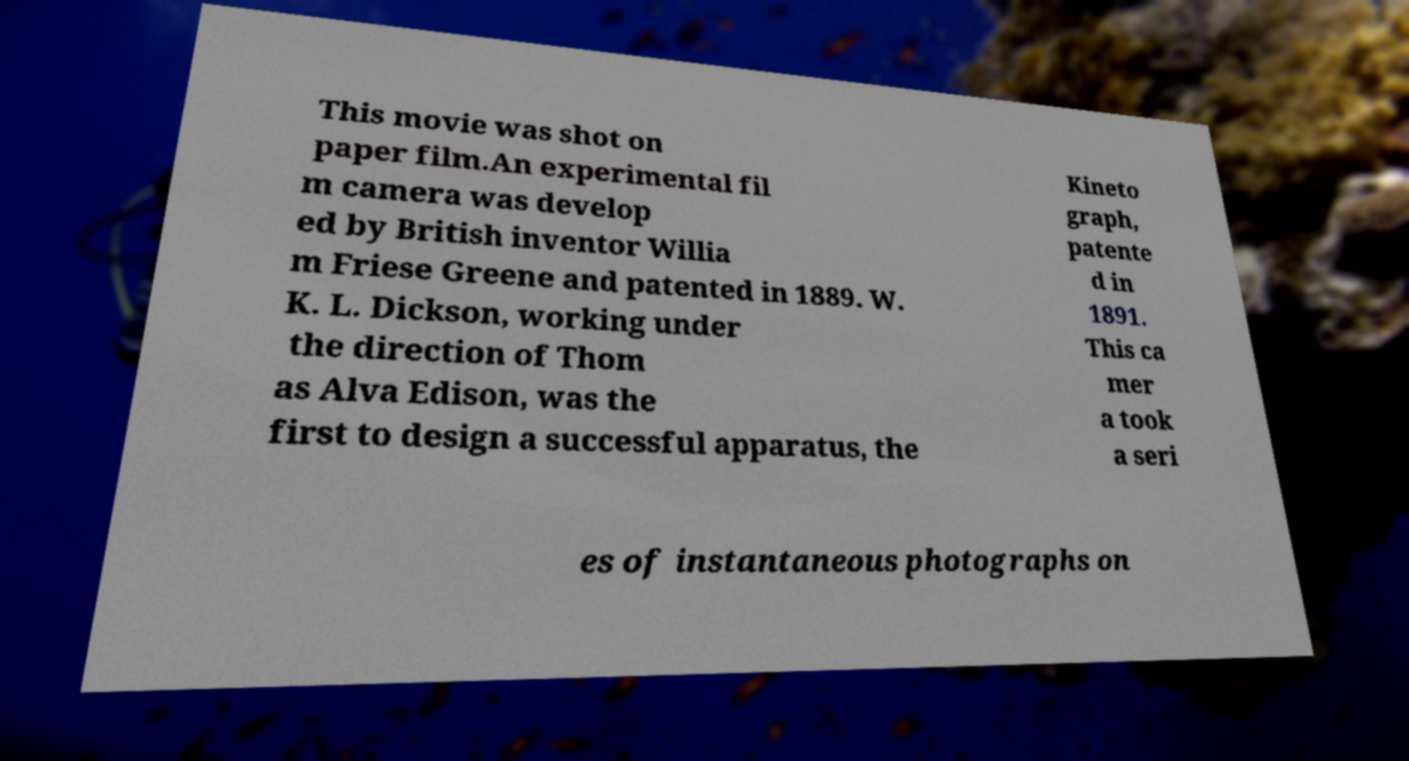Please read and relay the text visible in this image. What does it say? This movie was shot on paper film.An experimental fil m camera was develop ed by British inventor Willia m Friese Greene and patented in 1889. W. K. L. Dickson, working under the direction of Thom as Alva Edison, was the first to design a successful apparatus, the Kineto graph, patente d in 1891. This ca mer a took a seri es of instantaneous photographs on 